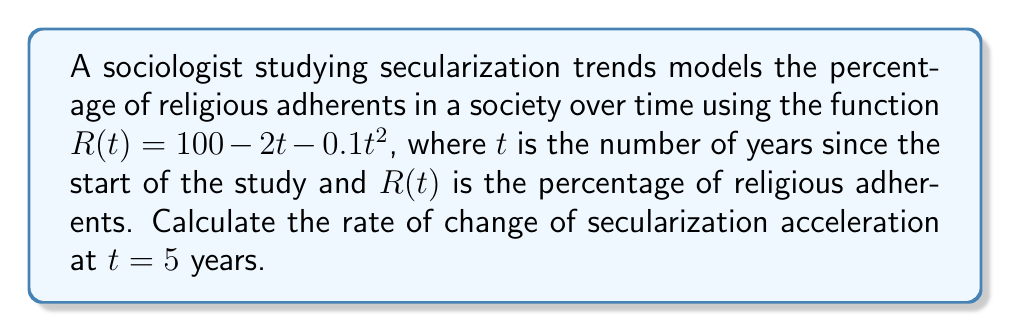Can you solve this math problem? To solve this problem, we need to follow these steps:

1) First, we need to understand what the question is asking. The rate of change of secularization acceleration is the third derivative of the religious adherents function $R(t)$.

2) Let's start by finding the first derivative of $R(t)$:
   $$R'(t) = -2 - 0.2t$$
   This represents the rate of change of religious adherents, or the velocity of secularization.

3) Now, let's find the second derivative:
   $$R''(t) = -0.2$$
   This represents the acceleration of secularization.

4) Finally, we need to find the third derivative:
   $$R'''(t) = 0$$

5) The question asks for the rate of change of secularization acceleration at $t = 5$. Since $R'''(t)$ is a constant (0), its value is the same for all $t$, including $t = 5$.
Answer: $0$ 